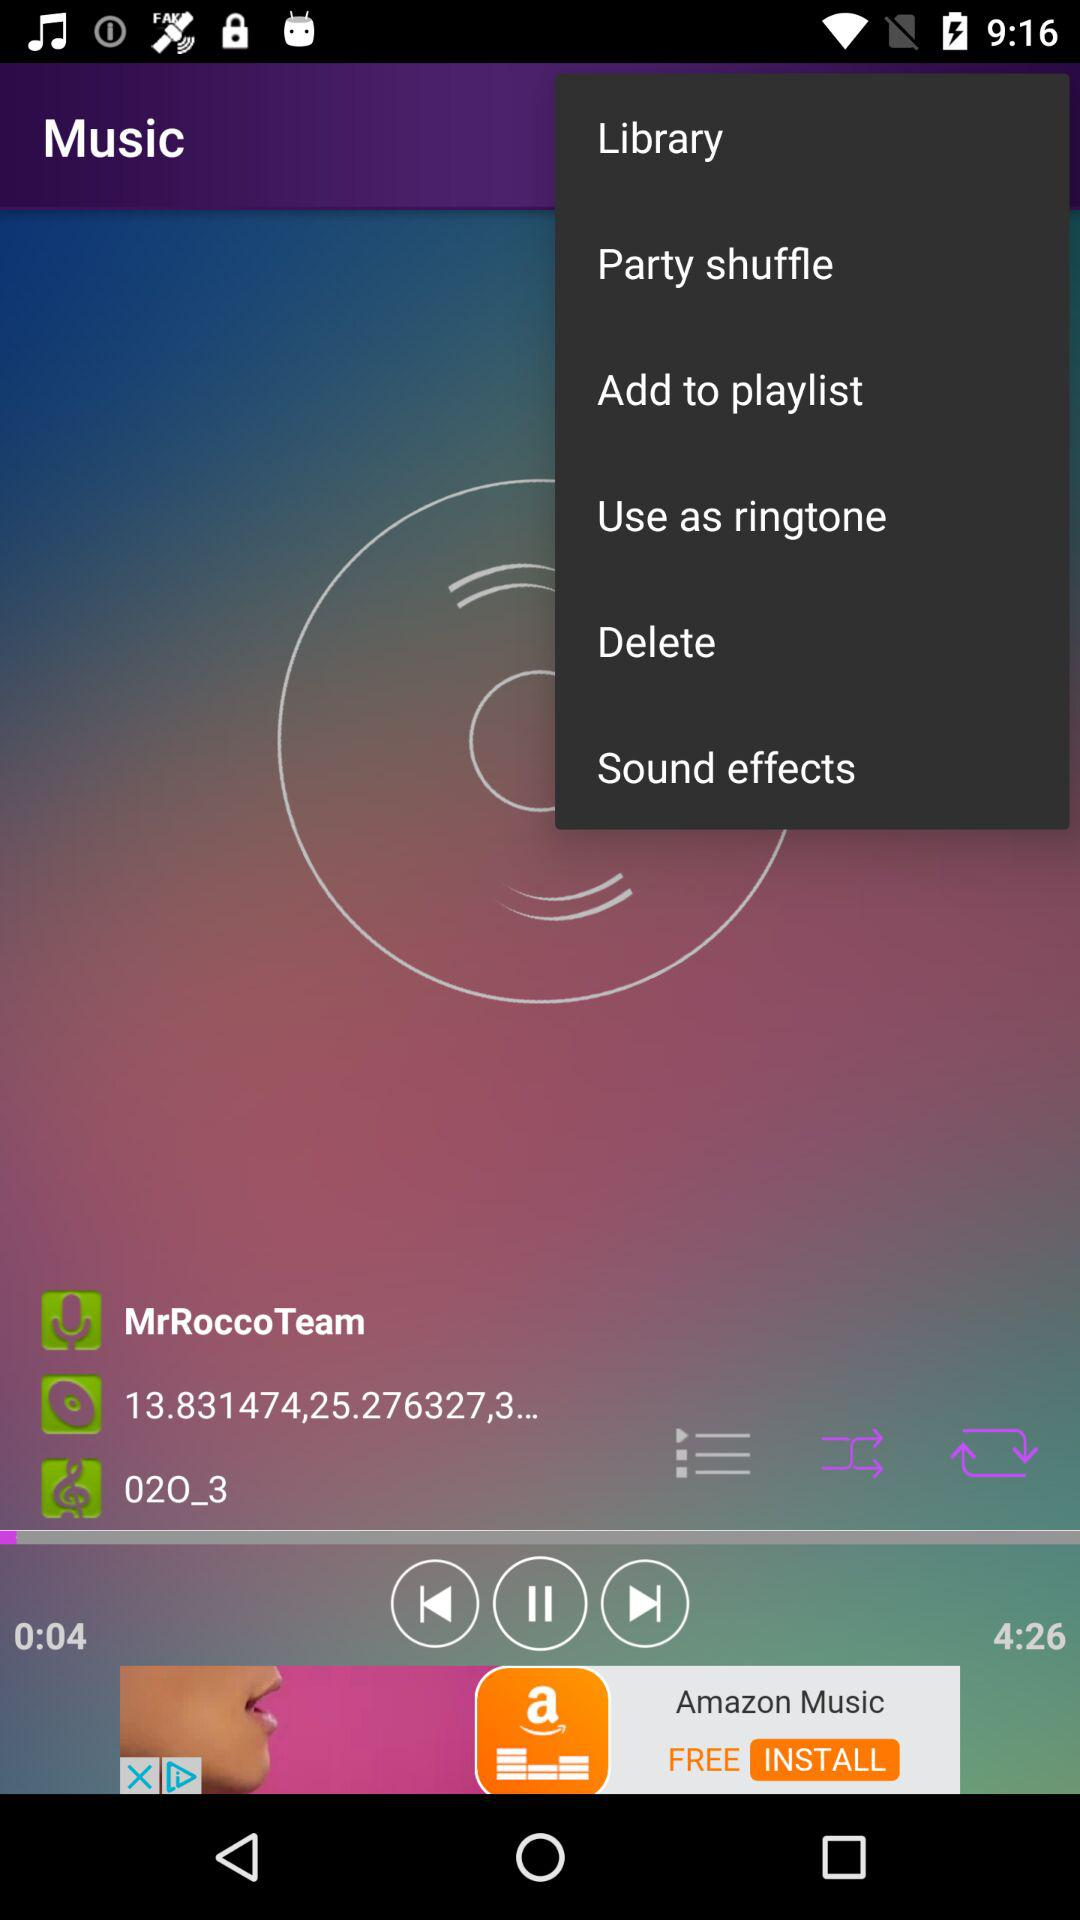Who is the singer of the song? The singer of the song is "MrRoccoTeam". 